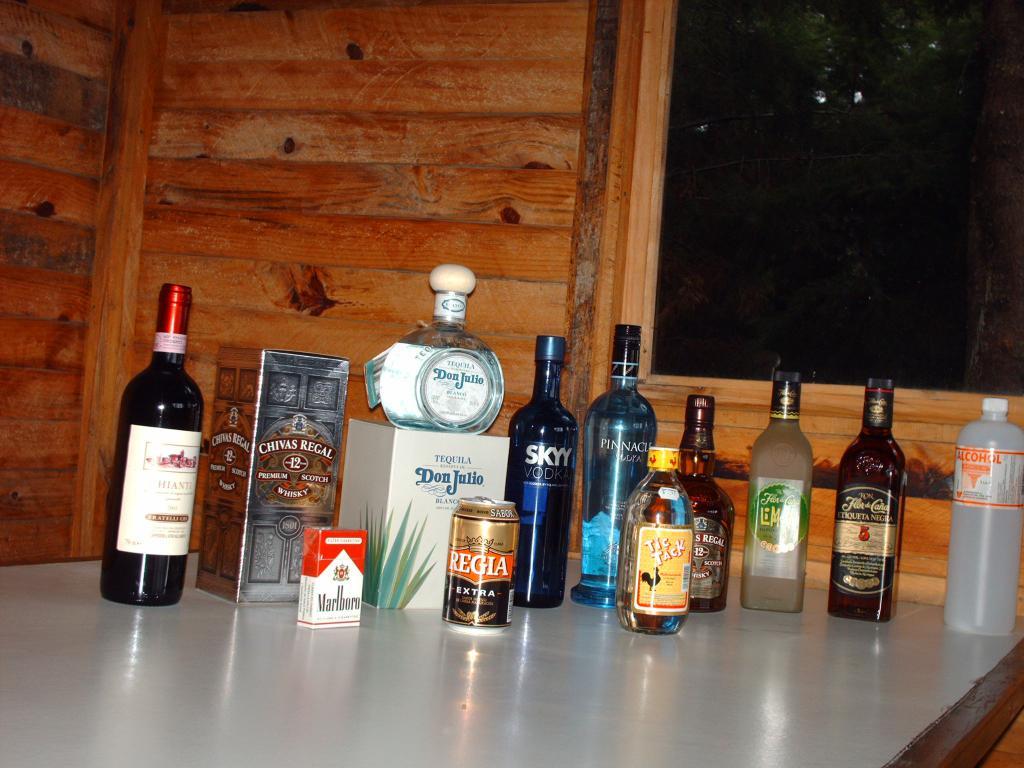What brand of cigarettes are on the table?
Offer a terse response. Marlboro. What's the blue bottle?
Provide a short and direct response. Skyy vodka. 